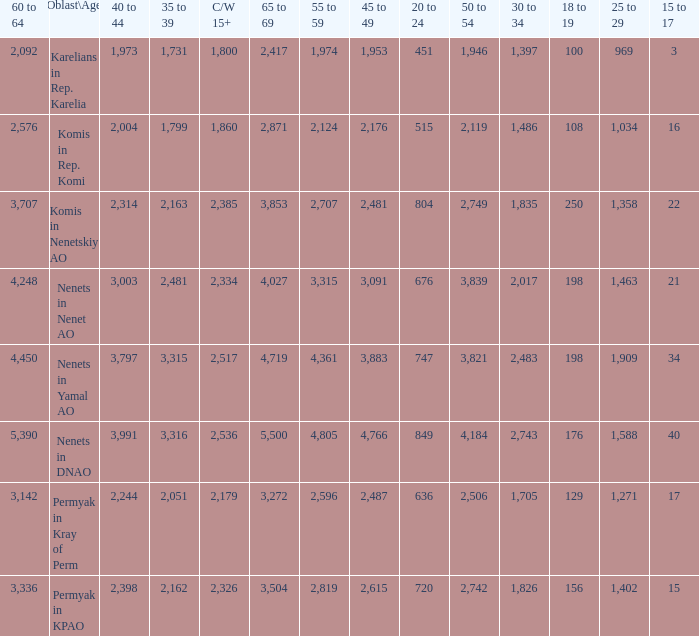What is the total 60 to 64 when the Oblast\Age is Nenets in Yamal AO, and the 45 to 49 is bigger than 3,883? None. 